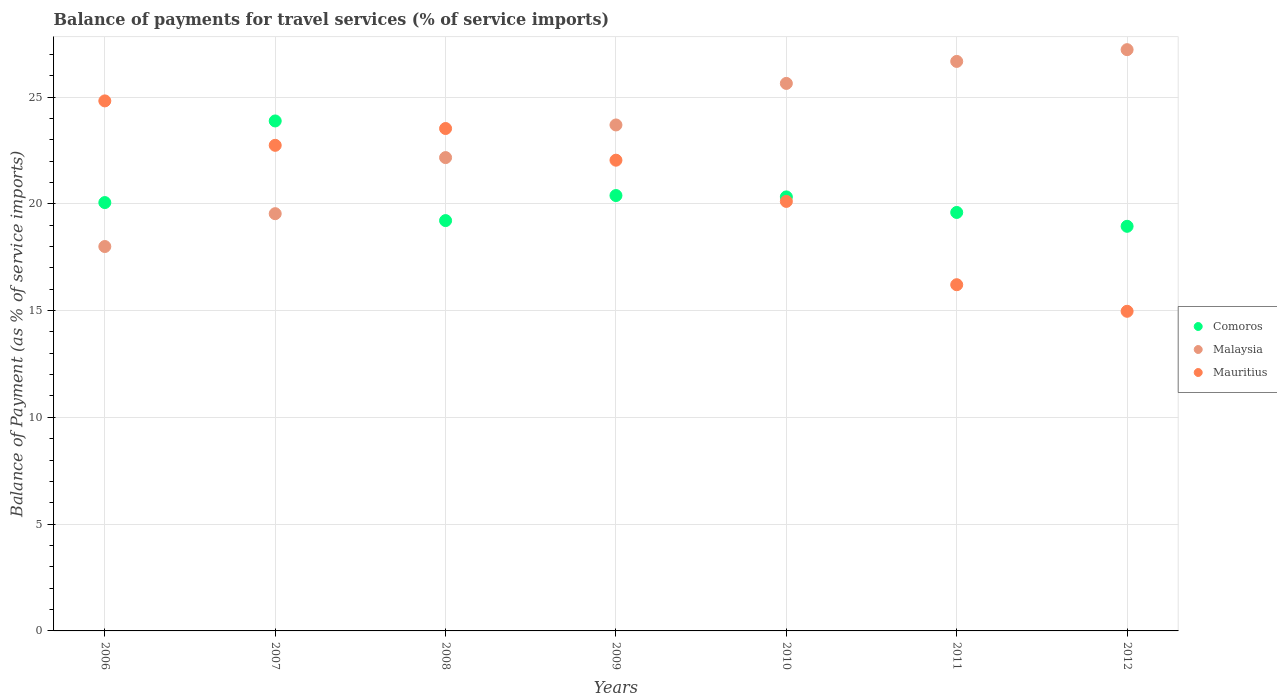Is the number of dotlines equal to the number of legend labels?
Your answer should be compact. Yes. What is the balance of payments for travel services in Comoros in 2009?
Offer a very short reply. 20.39. Across all years, what is the maximum balance of payments for travel services in Comoros?
Ensure brevity in your answer.  23.88. Across all years, what is the minimum balance of payments for travel services in Malaysia?
Give a very brief answer. 18. In which year was the balance of payments for travel services in Comoros maximum?
Keep it short and to the point. 2007. In which year was the balance of payments for travel services in Comoros minimum?
Give a very brief answer. 2012. What is the total balance of payments for travel services in Comoros in the graph?
Provide a succinct answer. 142.4. What is the difference between the balance of payments for travel services in Mauritius in 2007 and that in 2009?
Your response must be concise. 0.7. What is the difference between the balance of payments for travel services in Mauritius in 2012 and the balance of payments for travel services in Comoros in 2008?
Offer a terse response. -4.25. What is the average balance of payments for travel services in Mauritius per year?
Make the answer very short. 20.63. In the year 2007, what is the difference between the balance of payments for travel services in Malaysia and balance of payments for travel services in Comoros?
Offer a very short reply. -4.34. What is the ratio of the balance of payments for travel services in Mauritius in 2006 to that in 2010?
Make the answer very short. 1.23. Is the balance of payments for travel services in Malaysia in 2010 less than that in 2011?
Your answer should be very brief. Yes. What is the difference between the highest and the second highest balance of payments for travel services in Comoros?
Keep it short and to the point. 3.49. What is the difference between the highest and the lowest balance of payments for travel services in Malaysia?
Give a very brief answer. 9.22. What is the difference between two consecutive major ticks on the Y-axis?
Ensure brevity in your answer.  5. Does the graph contain grids?
Give a very brief answer. Yes. How many legend labels are there?
Offer a very short reply. 3. What is the title of the graph?
Give a very brief answer. Balance of payments for travel services (% of service imports). Does "Aruba" appear as one of the legend labels in the graph?
Your answer should be very brief. No. What is the label or title of the Y-axis?
Offer a terse response. Balance of Payment (as % of service imports). What is the Balance of Payment (as % of service imports) in Comoros in 2006?
Your answer should be very brief. 20.06. What is the Balance of Payment (as % of service imports) in Malaysia in 2006?
Your answer should be very brief. 18. What is the Balance of Payment (as % of service imports) of Mauritius in 2006?
Offer a terse response. 24.82. What is the Balance of Payment (as % of service imports) in Comoros in 2007?
Keep it short and to the point. 23.88. What is the Balance of Payment (as % of service imports) in Malaysia in 2007?
Give a very brief answer. 19.54. What is the Balance of Payment (as % of service imports) in Mauritius in 2007?
Provide a short and direct response. 22.74. What is the Balance of Payment (as % of service imports) in Comoros in 2008?
Ensure brevity in your answer.  19.21. What is the Balance of Payment (as % of service imports) in Malaysia in 2008?
Give a very brief answer. 22.16. What is the Balance of Payment (as % of service imports) in Mauritius in 2008?
Your response must be concise. 23.52. What is the Balance of Payment (as % of service imports) of Comoros in 2009?
Keep it short and to the point. 20.39. What is the Balance of Payment (as % of service imports) in Malaysia in 2009?
Ensure brevity in your answer.  23.69. What is the Balance of Payment (as % of service imports) of Mauritius in 2009?
Your answer should be compact. 22.04. What is the Balance of Payment (as % of service imports) of Comoros in 2010?
Provide a short and direct response. 20.32. What is the Balance of Payment (as % of service imports) of Malaysia in 2010?
Offer a terse response. 25.64. What is the Balance of Payment (as % of service imports) in Mauritius in 2010?
Ensure brevity in your answer.  20.11. What is the Balance of Payment (as % of service imports) in Comoros in 2011?
Make the answer very short. 19.59. What is the Balance of Payment (as % of service imports) in Malaysia in 2011?
Offer a terse response. 26.67. What is the Balance of Payment (as % of service imports) in Mauritius in 2011?
Offer a terse response. 16.21. What is the Balance of Payment (as % of service imports) of Comoros in 2012?
Provide a short and direct response. 18.95. What is the Balance of Payment (as % of service imports) of Malaysia in 2012?
Your answer should be compact. 27.22. What is the Balance of Payment (as % of service imports) of Mauritius in 2012?
Offer a very short reply. 14.97. Across all years, what is the maximum Balance of Payment (as % of service imports) in Comoros?
Make the answer very short. 23.88. Across all years, what is the maximum Balance of Payment (as % of service imports) in Malaysia?
Your response must be concise. 27.22. Across all years, what is the maximum Balance of Payment (as % of service imports) in Mauritius?
Provide a succinct answer. 24.82. Across all years, what is the minimum Balance of Payment (as % of service imports) in Comoros?
Offer a terse response. 18.95. Across all years, what is the minimum Balance of Payment (as % of service imports) of Malaysia?
Your answer should be compact. 18. Across all years, what is the minimum Balance of Payment (as % of service imports) in Mauritius?
Offer a very short reply. 14.97. What is the total Balance of Payment (as % of service imports) in Comoros in the graph?
Offer a terse response. 142.4. What is the total Balance of Payment (as % of service imports) of Malaysia in the graph?
Your answer should be very brief. 162.91. What is the total Balance of Payment (as % of service imports) in Mauritius in the graph?
Make the answer very short. 144.41. What is the difference between the Balance of Payment (as % of service imports) in Comoros in 2006 and that in 2007?
Offer a very short reply. -3.82. What is the difference between the Balance of Payment (as % of service imports) of Malaysia in 2006 and that in 2007?
Offer a very short reply. -1.54. What is the difference between the Balance of Payment (as % of service imports) in Mauritius in 2006 and that in 2007?
Make the answer very short. 2.08. What is the difference between the Balance of Payment (as % of service imports) in Comoros in 2006 and that in 2008?
Give a very brief answer. 0.84. What is the difference between the Balance of Payment (as % of service imports) of Malaysia in 2006 and that in 2008?
Provide a succinct answer. -4.16. What is the difference between the Balance of Payment (as % of service imports) in Mauritius in 2006 and that in 2008?
Make the answer very short. 1.29. What is the difference between the Balance of Payment (as % of service imports) of Comoros in 2006 and that in 2009?
Your response must be concise. -0.33. What is the difference between the Balance of Payment (as % of service imports) in Malaysia in 2006 and that in 2009?
Make the answer very short. -5.69. What is the difference between the Balance of Payment (as % of service imports) in Mauritius in 2006 and that in 2009?
Offer a very short reply. 2.78. What is the difference between the Balance of Payment (as % of service imports) in Comoros in 2006 and that in 2010?
Provide a short and direct response. -0.27. What is the difference between the Balance of Payment (as % of service imports) of Malaysia in 2006 and that in 2010?
Your answer should be very brief. -7.64. What is the difference between the Balance of Payment (as % of service imports) of Mauritius in 2006 and that in 2010?
Give a very brief answer. 4.71. What is the difference between the Balance of Payment (as % of service imports) of Comoros in 2006 and that in 2011?
Offer a very short reply. 0.46. What is the difference between the Balance of Payment (as % of service imports) of Malaysia in 2006 and that in 2011?
Provide a succinct answer. -8.67. What is the difference between the Balance of Payment (as % of service imports) in Mauritius in 2006 and that in 2011?
Provide a short and direct response. 8.61. What is the difference between the Balance of Payment (as % of service imports) in Comoros in 2006 and that in 2012?
Ensure brevity in your answer.  1.11. What is the difference between the Balance of Payment (as % of service imports) in Malaysia in 2006 and that in 2012?
Your answer should be compact. -9.22. What is the difference between the Balance of Payment (as % of service imports) of Mauritius in 2006 and that in 2012?
Offer a terse response. 9.85. What is the difference between the Balance of Payment (as % of service imports) in Comoros in 2007 and that in 2008?
Offer a very short reply. 4.67. What is the difference between the Balance of Payment (as % of service imports) of Malaysia in 2007 and that in 2008?
Keep it short and to the point. -2.63. What is the difference between the Balance of Payment (as % of service imports) of Mauritius in 2007 and that in 2008?
Make the answer very short. -0.79. What is the difference between the Balance of Payment (as % of service imports) of Comoros in 2007 and that in 2009?
Provide a short and direct response. 3.49. What is the difference between the Balance of Payment (as % of service imports) in Malaysia in 2007 and that in 2009?
Your answer should be compact. -4.15. What is the difference between the Balance of Payment (as % of service imports) in Mauritius in 2007 and that in 2009?
Provide a short and direct response. 0.7. What is the difference between the Balance of Payment (as % of service imports) in Comoros in 2007 and that in 2010?
Ensure brevity in your answer.  3.56. What is the difference between the Balance of Payment (as % of service imports) of Malaysia in 2007 and that in 2010?
Your response must be concise. -6.1. What is the difference between the Balance of Payment (as % of service imports) in Mauritius in 2007 and that in 2010?
Offer a terse response. 2.63. What is the difference between the Balance of Payment (as % of service imports) in Comoros in 2007 and that in 2011?
Your answer should be very brief. 4.28. What is the difference between the Balance of Payment (as % of service imports) of Malaysia in 2007 and that in 2011?
Your answer should be compact. -7.13. What is the difference between the Balance of Payment (as % of service imports) of Mauritius in 2007 and that in 2011?
Offer a terse response. 6.53. What is the difference between the Balance of Payment (as % of service imports) of Comoros in 2007 and that in 2012?
Provide a short and direct response. 4.93. What is the difference between the Balance of Payment (as % of service imports) in Malaysia in 2007 and that in 2012?
Provide a short and direct response. -7.68. What is the difference between the Balance of Payment (as % of service imports) in Mauritius in 2007 and that in 2012?
Offer a terse response. 7.77. What is the difference between the Balance of Payment (as % of service imports) of Comoros in 2008 and that in 2009?
Offer a terse response. -1.17. What is the difference between the Balance of Payment (as % of service imports) of Malaysia in 2008 and that in 2009?
Ensure brevity in your answer.  -1.53. What is the difference between the Balance of Payment (as % of service imports) in Mauritius in 2008 and that in 2009?
Provide a succinct answer. 1.48. What is the difference between the Balance of Payment (as % of service imports) in Comoros in 2008 and that in 2010?
Give a very brief answer. -1.11. What is the difference between the Balance of Payment (as % of service imports) of Malaysia in 2008 and that in 2010?
Make the answer very short. -3.47. What is the difference between the Balance of Payment (as % of service imports) in Mauritius in 2008 and that in 2010?
Offer a very short reply. 3.41. What is the difference between the Balance of Payment (as % of service imports) in Comoros in 2008 and that in 2011?
Give a very brief answer. -0.38. What is the difference between the Balance of Payment (as % of service imports) of Malaysia in 2008 and that in 2011?
Offer a terse response. -4.5. What is the difference between the Balance of Payment (as % of service imports) in Mauritius in 2008 and that in 2011?
Make the answer very short. 7.31. What is the difference between the Balance of Payment (as % of service imports) in Comoros in 2008 and that in 2012?
Your response must be concise. 0.27. What is the difference between the Balance of Payment (as % of service imports) of Malaysia in 2008 and that in 2012?
Provide a succinct answer. -5.05. What is the difference between the Balance of Payment (as % of service imports) in Mauritius in 2008 and that in 2012?
Your response must be concise. 8.56. What is the difference between the Balance of Payment (as % of service imports) of Comoros in 2009 and that in 2010?
Keep it short and to the point. 0.06. What is the difference between the Balance of Payment (as % of service imports) of Malaysia in 2009 and that in 2010?
Your answer should be very brief. -1.95. What is the difference between the Balance of Payment (as % of service imports) in Mauritius in 2009 and that in 2010?
Provide a succinct answer. 1.93. What is the difference between the Balance of Payment (as % of service imports) in Comoros in 2009 and that in 2011?
Offer a very short reply. 0.79. What is the difference between the Balance of Payment (as % of service imports) in Malaysia in 2009 and that in 2011?
Give a very brief answer. -2.98. What is the difference between the Balance of Payment (as % of service imports) of Mauritius in 2009 and that in 2011?
Make the answer very short. 5.83. What is the difference between the Balance of Payment (as % of service imports) of Comoros in 2009 and that in 2012?
Ensure brevity in your answer.  1.44. What is the difference between the Balance of Payment (as % of service imports) of Malaysia in 2009 and that in 2012?
Your answer should be compact. -3.53. What is the difference between the Balance of Payment (as % of service imports) of Mauritius in 2009 and that in 2012?
Keep it short and to the point. 7.08. What is the difference between the Balance of Payment (as % of service imports) in Comoros in 2010 and that in 2011?
Your response must be concise. 0.73. What is the difference between the Balance of Payment (as % of service imports) in Malaysia in 2010 and that in 2011?
Your answer should be very brief. -1.03. What is the difference between the Balance of Payment (as % of service imports) of Mauritius in 2010 and that in 2011?
Ensure brevity in your answer.  3.9. What is the difference between the Balance of Payment (as % of service imports) of Comoros in 2010 and that in 2012?
Your response must be concise. 1.38. What is the difference between the Balance of Payment (as % of service imports) of Malaysia in 2010 and that in 2012?
Offer a terse response. -1.58. What is the difference between the Balance of Payment (as % of service imports) of Mauritius in 2010 and that in 2012?
Keep it short and to the point. 5.15. What is the difference between the Balance of Payment (as % of service imports) of Comoros in 2011 and that in 2012?
Provide a succinct answer. 0.65. What is the difference between the Balance of Payment (as % of service imports) in Malaysia in 2011 and that in 2012?
Your response must be concise. -0.55. What is the difference between the Balance of Payment (as % of service imports) of Mauritius in 2011 and that in 2012?
Your answer should be very brief. 1.24. What is the difference between the Balance of Payment (as % of service imports) in Comoros in 2006 and the Balance of Payment (as % of service imports) in Malaysia in 2007?
Your response must be concise. 0.52. What is the difference between the Balance of Payment (as % of service imports) of Comoros in 2006 and the Balance of Payment (as % of service imports) of Mauritius in 2007?
Make the answer very short. -2.68. What is the difference between the Balance of Payment (as % of service imports) of Malaysia in 2006 and the Balance of Payment (as % of service imports) of Mauritius in 2007?
Your answer should be compact. -4.74. What is the difference between the Balance of Payment (as % of service imports) in Comoros in 2006 and the Balance of Payment (as % of service imports) in Malaysia in 2008?
Provide a short and direct response. -2.11. What is the difference between the Balance of Payment (as % of service imports) of Comoros in 2006 and the Balance of Payment (as % of service imports) of Mauritius in 2008?
Ensure brevity in your answer.  -3.47. What is the difference between the Balance of Payment (as % of service imports) of Malaysia in 2006 and the Balance of Payment (as % of service imports) of Mauritius in 2008?
Offer a terse response. -5.53. What is the difference between the Balance of Payment (as % of service imports) in Comoros in 2006 and the Balance of Payment (as % of service imports) in Malaysia in 2009?
Provide a short and direct response. -3.63. What is the difference between the Balance of Payment (as % of service imports) of Comoros in 2006 and the Balance of Payment (as % of service imports) of Mauritius in 2009?
Your answer should be compact. -1.98. What is the difference between the Balance of Payment (as % of service imports) of Malaysia in 2006 and the Balance of Payment (as % of service imports) of Mauritius in 2009?
Give a very brief answer. -4.04. What is the difference between the Balance of Payment (as % of service imports) of Comoros in 2006 and the Balance of Payment (as % of service imports) of Malaysia in 2010?
Give a very brief answer. -5.58. What is the difference between the Balance of Payment (as % of service imports) of Comoros in 2006 and the Balance of Payment (as % of service imports) of Mauritius in 2010?
Your answer should be very brief. -0.05. What is the difference between the Balance of Payment (as % of service imports) in Malaysia in 2006 and the Balance of Payment (as % of service imports) in Mauritius in 2010?
Provide a succinct answer. -2.11. What is the difference between the Balance of Payment (as % of service imports) in Comoros in 2006 and the Balance of Payment (as % of service imports) in Malaysia in 2011?
Your answer should be compact. -6.61. What is the difference between the Balance of Payment (as % of service imports) of Comoros in 2006 and the Balance of Payment (as % of service imports) of Mauritius in 2011?
Offer a very short reply. 3.85. What is the difference between the Balance of Payment (as % of service imports) of Malaysia in 2006 and the Balance of Payment (as % of service imports) of Mauritius in 2011?
Make the answer very short. 1.79. What is the difference between the Balance of Payment (as % of service imports) in Comoros in 2006 and the Balance of Payment (as % of service imports) in Malaysia in 2012?
Your answer should be compact. -7.16. What is the difference between the Balance of Payment (as % of service imports) of Comoros in 2006 and the Balance of Payment (as % of service imports) of Mauritius in 2012?
Keep it short and to the point. 5.09. What is the difference between the Balance of Payment (as % of service imports) of Malaysia in 2006 and the Balance of Payment (as % of service imports) of Mauritius in 2012?
Ensure brevity in your answer.  3.03. What is the difference between the Balance of Payment (as % of service imports) in Comoros in 2007 and the Balance of Payment (as % of service imports) in Malaysia in 2008?
Make the answer very short. 1.72. What is the difference between the Balance of Payment (as % of service imports) of Comoros in 2007 and the Balance of Payment (as % of service imports) of Mauritius in 2008?
Offer a terse response. 0.35. What is the difference between the Balance of Payment (as % of service imports) of Malaysia in 2007 and the Balance of Payment (as % of service imports) of Mauritius in 2008?
Provide a short and direct response. -3.99. What is the difference between the Balance of Payment (as % of service imports) of Comoros in 2007 and the Balance of Payment (as % of service imports) of Malaysia in 2009?
Provide a short and direct response. 0.19. What is the difference between the Balance of Payment (as % of service imports) in Comoros in 2007 and the Balance of Payment (as % of service imports) in Mauritius in 2009?
Give a very brief answer. 1.84. What is the difference between the Balance of Payment (as % of service imports) of Malaysia in 2007 and the Balance of Payment (as % of service imports) of Mauritius in 2009?
Offer a very short reply. -2.5. What is the difference between the Balance of Payment (as % of service imports) in Comoros in 2007 and the Balance of Payment (as % of service imports) in Malaysia in 2010?
Provide a succinct answer. -1.76. What is the difference between the Balance of Payment (as % of service imports) of Comoros in 2007 and the Balance of Payment (as % of service imports) of Mauritius in 2010?
Your answer should be very brief. 3.77. What is the difference between the Balance of Payment (as % of service imports) of Malaysia in 2007 and the Balance of Payment (as % of service imports) of Mauritius in 2010?
Make the answer very short. -0.57. What is the difference between the Balance of Payment (as % of service imports) of Comoros in 2007 and the Balance of Payment (as % of service imports) of Malaysia in 2011?
Offer a terse response. -2.79. What is the difference between the Balance of Payment (as % of service imports) in Comoros in 2007 and the Balance of Payment (as % of service imports) in Mauritius in 2011?
Offer a terse response. 7.67. What is the difference between the Balance of Payment (as % of service imports) of Malaysia in 2007 and the Balance of Payment (as % of service imports) of Mauritius in 2011?
Your answer should be compact. 3.33. What is the difference between the Balance of Payment (as % of service imports) in Comoros in 2007 and the Balance of Payment (as % of service imports) in Malaysia in 2012?
Provide a short and direct response. -3.34. What is the difference between the Balance of Payment (as % of service imports) of Comoros in 2007 and the Balance of Payment (as % of service imports) of Mauritius in 2012?
Your response must be concise. 8.91. What is the difference between the Balance of Payment (as % of service imports) of Malaysia in 2007 and the Balance of Payment (as % of service imports) of Mauritius in 2012?
Give a very brief answer. 4.57. What is the difference between the Balance of Payment (as % of service imports) in Comoros in 2008 and the Balance of Payment (as % of service imports) in Malaysia in 2009?
Offer a terse response. -4.48. What is the difference between the Balance of Payment (as % of service imports) of Comoros in 2008 and the Balance of Payment (as % of service imports) of Mauritius in 2009?
Your answer should be compact. -2.83. What is the difference between the Balance of Payment (as % of service imports) of Malaysia in 2008 and the Balance of Payment (as % of service imports) of Mauritius in 2009?
Ensure brevity in your answer.  0.12. What is the difference between the Balance of Payment (as % of service imports) of Comoros in 2008 and the Balance of Payment (as % of service imports) of Malaysia in 2010?
Offer a very short reply. -6.42. What is the difference between the Balance of Payment (as % of service imports) in Comoros in 2008 and the Balance of Payment (as % of service imports) in Mauritius in 2010?
Ensure brevity in your answer.  -0.9. What is the difference between the Balance of Payment (as % of service imports) of Malaysia in 2008 and the Balance of Payment (as % of service imports) of Mauritius in 2010?
Ensure brevity in your answer.  2.05. What is the difference between the Balance of Payment (as % of service imports) of Comoros in 2008 and the Balance of Payment (as % of service imports) of Malaysia in 2011?
Your response must be concise. -7.45. What is the difference between the Balance of Payment (as % of service imports) of Comoros in 2008 and the Balance of Payment (as % of service imports) of Mauritius in 2011?
Provide a succinct answer. 3. What is the difference between the Balance of Payment (as % of service imports) in Malaysia in 2008 and the Balance of Payment (as % of service imports) in Mauritius in 2011?
Keep it short and to the point. 5.95. What is the difference between the Balance of Payment (as % of service imports) in Comoros in 2008 and the Balance of Payment (as % of service imports) in Malaysia in 2012?
Your answer should be compact. -8. What is the difference between the Balance of Payment (as % of service imports) of Comoros in 2008 and the Balance of Payment (as % of service imports) of Mauritius in 2012?
Provide a succinct answer. 4.25. What is the difference between the Balance of Payment (as % of service imports) in Malaysia in 2008 and the Balance of Payment (as % of service imports) in Mauritius in 2012?
Provide a succinct answer. 7.2. What is the difference between the Balance of Payment (as % of service imports) in Comoros in 2009 and the Balance of Payment (as % of service imports) in Malaysia in 2010?
Give a very brief answer. -5.25. What is the difference between the Balance of Payment (as % of service imports) of Comoros in 2009 and the Balance of Payment (as % of service imports) of Mauritius in 2010?
Your answer should be compact. 0.27. What is the difference between the Balance of Payment (as % of service imports) of Malaysia in 2009 and the Balance of Payment (as % of service imports) of Mauritius in 2010?
Make the answer very short. 3.58. What is the difference between the Balance of Payment (as % of service imports) of Comoros in 2009 and the Balance of Payment (as % of service imports) of Malaysia in 2011?
Your answer should be compact. -6.28. What is the difference between the Balance of Payment (as % of service imports) in Comoros in 2009 and the Balance of Payment (as % of service imports) in Mauritius in 2011?
Provide a short and direct response. 4.18. What is the difference between the Balance of Payment (as % of service imports) of Malaysia in 2009 and the Balance of Payment (as % of service imports) of Mauritius in 2011?
Your answer should be very brief. 7.48. What is the difference between the Balance of Payment (as % of service imports) in Comoros in 2009 and the Balance of Payment (as % of service imports) in Malaysia in 2012?
Your response must be concise. -6.83. What is the difference between the Balance of Payment (as % of service imports) in Comoros in 2009 and the Balance of Payment (as % of service imports) in Mauritius in 2012?
Your answer should be very brief. 5.42. What is the difference between the Balance of Payment (as % of service imports) in Malaysia in 2009 and the Balance of Payment (as % of service imports) in Mauritius in 2012?
Make the answer very short. 8.73. What is the difference between the Balance of Payment (as % of service imports) in Comoros in 2010 and the Balance of Payment (as % of service imports) in Malaysia in 2011?
Your answer should be very brief. -6.34. What is the difference between the Balance of Payment (as % of service imports) in Comoros in 2010 and the Balance of Payment (as % of service imports) in Mauritius in 2011?
Your answer should be very brief. 4.11. What is the difference between the Balance of Payment (as % of service imports) of Malaysia in 2010 and the Balance of Payment (as % of service imports) of Mauritius in 2011?
Provide a succinct answer. 9.43. What is the difference between the Balance of Payment (as % of service imports) of Comoros in 2010 and the Balance of Payment (as % of service imports) of Malaysia in 2012?
Offer a terse response. -6.89. What is the difference between the Balance of Payment (as % of service imports) in Comoros in 2010 and the Balance of Payment (as % of service imports) in Mauritius in 2012?
Give a very brief answer. 5.36. What is the difference between the Balance of Payment (as % of service imports) of Malaysia in 2010 and the Balance of Payment (as % of service imports) of Mauritius in 2012?
Make the answer very short. 10.67. What is the difference between the Balance of Payment (as % of service imports) in Comoros in 2011 and the Balance of Payment (as % of service imports) in Malaysia in 2012?
Ensure brevity in your answer.  -7.62. What is the difference between the Balance of Payment (as % of service imports) of Comoros in 2011 and the Balance of Payment (as % of service imports) of Mauritius in 2012?
Offer a very short reply. 4.63. What is the difference between the Balance of Payment (as % of service imports) of Malaysia in 2011 and the Balance of Payment (as % of service imports) of Mauritius in 2012?
Provide a succinct answer. 11.7. What is the average Balance of Payment (as % of service imports) of Comoros per year?
Keep it short and to the point. 20.34. What is the average Balance of Payment (as % of service imports) of Malaysia per year?
Keep it short and to the point. 23.27. What is the average Balance of Payment (as % of service imports) of Mauritius per year?
Make the answer very short. 20.63. In the year 2006, what is the difference between the Balance of Payment (as % of service imports) in Comoros and Balance of Payment (as % of service imports) in Malaysia?
Your answer should be compact. 2.06. In the year 2006, what is the difference between the Balance of Payment (as % of service imports) of Comoros and Balance of Payment (as % of service imports) of Mauritius?
Provide a succinct answer. -4.76. In the year 2006, what is the difference between the Balance of Payment (as % of service imports) in Malaysia and Balance of Payment (as % of service imports) in Mauritius?
Provide a short and direct response. -6.82. In the year 2007, what is the difference between the Balance of Payment (as % of service imports) in Comoros and Balance of Payment (as % of service imports) in Malaysia?
Make the answer very short. 4.34. In the year 2007, what is the difference between the Balance of Payment (as % of service imports) in Comoros and Balance of Payment (as % of service imports) in Mauritius?
Your response must be concise. 1.14. In the year 2007, what is the difference between the Balance of Payment (as % of service imports) of Malaysia and Balance of Payment (as % of service imports) of Mauritius?
Offer a very short reply. -3.2. In the year 2008, what is the difference between the Balance of Payment (as % of service imports) of Comoros and Balance of Payment (as % of service imports) of Malaysia?
Provide a short and direct response. -2.95. In the year 2008, what is the difference between the Balance of Payment (as % of service imports) in Comoros and Balance of Payment (as % of service imports) in Mauritius?
Give a very brief answer. -4.31. In the year 2008, what is the difference between the Balance of Payment (as % of service imports) of Malaysia and Balance of Payment (as % of service imports) of Mauritius?
Make the answer very short. -1.36. In the year 2009, what is the difference between the Balance of Payment (as % of service imports) in Comoros and Balance of Payment (as % of service imports) in Malaysia?
Provide a succinct answer. -3.31. In the year 2009, what is the difference between the Balance of Payment (as % of service imports) of Comoros and Balance of Payment (as % of service imports) of Mauritius?
Give a very brief answer. -1.65. In the year 2009, what is the difference between the Balance of Payment (as % of service imports) of Malaysia and Balance of Payment (as % of service imports) of Mauritius?
Your answer should be very brief. 1.65. In the year 2010, what is the difference between the Balance of Payment (as % of service imports) in Comoros and Balance of Payment (as % of service imports) in Malaysia?
Your answer should be compact. -5.31. In the year 2010, what is the difference between the Balance of Payment (as % of service imports) of Comoros and Balance of Payment (as % of service imports) of Mauritius?
Your response must be concise. 0.21. In the year 2010, what is the difference between the Balance of Payment (as % of service imports) in Malaysia and Balance of Payment (as % of service imports) in Mauritius?
Keep it short and to the point. 5.53. In the year 2011, what is the difference between the Balance of Payment (as % of service imports) in Comoros and Balance of Payment (as % of service imports) in Malaysia?
Provide a short and direct response. -7.07. In the year 2011, what is the difference between the Balance of Payment (as % of service imports) in Comoros and Balance of Payment (as % of service imports) in Mauritius?
Keep it short and to the point. 3.38. In the year 2011, what is the difference between the Balance of Payment (as % of service imports) of Malaysia and Balance of Payment (as % of service imports) of Mauritius?
Give a very brief answer. 10.46. In the year 2012, what is the difference between the Balance of Payment (as % of service imports) of Comoros and Balance of Payment (as % of service imports) of Malaysia?
Offer a terse response. -8.27. In the year 2012, what is the difference between the Balance of Payment (as % of service imports) in Comoros and Balance of Payment (as % of service imports) in Mauritius?
Offer a terse response. 3.98. In the year 2012, what is the difference between the Balance of Payment (as % of service imports) in Malaysia and Balance of Payment (as % of service imports) in Mauritius?
Your response must be concise. 12.25. What is the ratio of the Balance of Payment (as % of service imports) in Comoros in 2006 to that in 2007?
Keep it short and to the point. 0.84. What is the ratio of the Balance of Payment (as % of service imports) of Malaysia in 2006 to that in 2007?
Offer a very short reply. 0.92. What is the ratio of the Balance of Payment (as % of service imports) in Mauritius in 2006 to that in 2007?
Offer a terse response. 1.09. What is the ratio of the Balance of Payment (as % of service imports) of Comoros in 2006 to that in 2008?
Make the answer very short. 1.04. What is the ratio of the Balance of Payment (as % of service imports) of Malaysia in 2006 to that in 2008?
Provide a short and direct response. 0.81. What is the ratio of the Balance of Payment (as % of service imports) in Mauritius in 2006 to that in 2008?
Ensure brevity in your answer.  1.05. What is the ratio of the Balance of Payment (as % of service imports) of Comoros in 2006 to that in 2009?
Keep it short and to the point. 0.98. What is the ratio of the Balance of Payment (as % of service imports) of Malaysia in 2006 to that in 2009?
Give a very brief answer. 0.76. What is the ratio of the Balance of Payment (as % of service imports) in Mauritius in 2006 to that in 2009?
Offer a very short reply. 1.13. What is the ratio of the Balance of Payment (as % of service imports) of Comoros in 2006 to that in 2010?
Offer a terse response. 0.99. What is the ratio of the Balance of Payment (as % of service imports) in Malaysia in 2006 to that in 2010?
Your answer should be compact. 0.7. What is the ratio of the Balance of Payment (as % of service imports) in Mauritius in 2006 to that in 2010?
Keep it short and to the point. 1.23. What is the ratio of the Balance of Payment (as % of service imports) in Comoros in 2006 to that in 2011?
Your answer should be compact. 1.02. What is the ratio of the Balance of Payment (as % of service imports) of Malaysia in 2006 to that in 2011?
Give a very brief answer. 0.68. What is the ratio of the Balance of Payment (as % of service imports) of Mauritius in 2006 to that in 2011?
Provide a short and direct response. 1.53. What is the ratio of the Balance of Payment (as % of service imports) in Comoros in 2006 to that in 2012?
Give a very brief answer. 1.06. What is the ratio of the Balance of Payment (as % of service imports) of Malaysia in 2006 to that in 2012?
Provide a succinct answer. 0.66. What is the ratio of the Balance of Payment (as % of service imports) in Mauritius in 2006 to that in 2012?
Your response must be concise. 1.66. What is the ratio of the Balance of Payment (as % of service imports) of Comoros in 2007 to that in 2008?
Your answer should be very brief. 1.24. What is the ratio of the Balance of Payment (as % of service imports) in Malaysia in 2007 to that in 2008?
Keep it short and to the point. 0.88. What is the ratio of the Balance of Payment (as % of service imports) in Mauritius in 2007 to that in 2008?
Your answer should be very brief. 0.97. What is the ratio of the Balance of Payment (as % of service imports) of Comoros in 2007 to that in 2009?
Ensure brevity in your answer.  1.17. What is the ratio of the Balance of Payment (as % of service imports) in Malaysia in 2007 to that in 2009?
Keep it short and to the point. 0.82. What is the ratio of the Balance of Payment (as % of service imports) in Mauritius in 2007 to that in 2009?
Keep it short and to the point. 1.03. What is the ratio of the Balance of Payment (as % of service imports) of Comoros in 2007 to that in 2010?
Offer a very short reply. 1.18. What is the ratio of the Balance of Payment (as % of service imports) in Malaysia in 2007 to that in 2010?
Give a very brief answer. 0.76. What is the ratio of the Balance of Payment (as % of service imports) of Mauritius in 2007 to that in 2010?
Your response must be concise. 1.13. What is the ratio of the Balance of Payment (as % of service imports) of Comoros in 2007 to that in 2011?
Make the answer very short. 1.22. What is the ratio of the Balance of Payment (as % of service imports) in Malaysia in 2007 to that in 2011?
Your answer should be compact. 0.73. What is the ratio of the Balance of Payment (as % of service imports) of Mauritius in 2007 to that in 2011?
Ensure brevity in your answer.  1.4. What is the ratio of the Balance of Payment (as % of service imports) of Comoros in 2007 to that in 2012?
Provide a succinct answer. 1.26. What is the ratio of the Balance of Payment (as % of service imports) of Malaysia in 2007 to that in 2012?
Provide a succinct answer. 0.72. What is the ratio of the Balance of Payment (as % of service imports) of Mauritius in 2007 to that in 2012?
Provide a short and direct response. 1.52. What is the ratio of the Balance of Payment (as % of service imports) of Comoros in 2008 to that in 2009?
Offer a terse response. 0.94. What is the ratio of the Balance of Payment (as % of service imports) of Malaysia in 2008 to that in 2009?
Keep it short and to the point. 0.94. What is the ratio of the Balance of Payment (as % of service imports) of Mauritius in 2008 to that in 2009?
Provide a succinct answer. 1.07. What is the ratio of the Balance of Payment (as % of service imports) of Comoros in 2008 to that in 2010?
Your answer should be compact. 0.95. What is the ratio of the Balance of Payment (as % of service imports) of Malaysia in 2008 to that in 2010?
Offer a very short reply. 0.86. What is the ratio of the Balance of Payment (as % of service imports) of Mauritius in 2008 to that in 2010?
Offer a terse response. 1.17. What is the ratio of the Balance of Payment (as % of service imports) in Comoros in 2008 to that in 2011?
Provide a succinct answer. 0.98. What is the ratio of the Balance of Payment (as % of service imports) in Malaysia in 2008 to that in 2011?
Provide a short and direct response. 0.83. What is the ratio of the Balance of Payment (as % of service imports) of Mauritius in 2008 to that in 2011?
Offer a very short reply. 1.45. What is the ratio of the Balance of Payment (as % of service imports) in Comoros in 2008 to that in 2012?
Ensure brevity in your answer.  1.01. What is the ratio of the Balance of Payment (as % of service imports) in Malaysia in 2008 to that in 2012?
Keep it short and to the point. 0.81. What is the ratio of the Balance of Payment (as % of service imports) in Mauritius in 2008 to that in 2012?
Your response must be concise. 1.57. What is the ratio of the Balance of Payment (as % of service imports) in Comoros in 2009 to that in 2010?
Your answer should be very brief. 1. What is the ratio of the Balance of Payment (as % of service imports) of Malaysia in 2009 to that in 2010?
Give a very brief answer. 0.92. What is the ratio of the Balance of Payment (as % of service imports) in Mauritius in 2009 to that in 2010?
Your answer should be very brief. 1.1. What is the ratio of the Balance of Payment (as % of service imports) in Comoros in 2009 to that in 2011?
Your response must be concise. 1.04. What is the ratio of the Balance of Payment (as % of service imports) of Malaysia in 2009 to that in 2011?
Provide a succinct answer. 0.89. What is the ratio of the Balance of Payment (as % of service imports) of Mauritius in 2009 to that in 2011?
Your answer should be very brief. 1.36. What is the ratio of the Balance of Payment (as % of service imports) in Comoros in 2009 to that in 2012?
Offer a very short reply. 1.08. What is the ratio of the Balance of Payment (as % of service imports) in Malaysia in 2009 to that in 2012?
Offer a very short reply. 0.87. What is the ratio of the Balance of Payment (as % of service imports) of Mauritius in 2009 to that in 2012?
Give a very brief answer. 1.47. What is the ratio of the Balance of Payment (as % of service imports) of Comoros in 2010 to that in 2011?
Your answer should be compact. 1.04. What is the ratio of the Balance of Payment (as % of service imports) of Malaysia in 2010 to that in 2011?
Ensure brevity in your answer.  0.96. What is the ratio of the Balance of Payment (as % of service imports) of Mauritius in 2010 to that in 2011?
Offer a very short reply. 1.24. What is the ratio of the Balance of Payment (as % of service imports) in Comoros in 2010 to that in 2012?
Offer a very short reply. 1.07. What is the ratio of the Balance of Payment (as % of service imports) in Malaysia in 2010 to that in 2012?
Make the answer very short. 0.94. What is the ratio of the Balance of Payment (as % of service imports) of Mauritius in 2010 to that in 2012?
Make the answer very short. 1.34. What is the ratio of the Balance of Payment (as % of service imports) in Comoros in 2011 to that in 2012?
Provide a short and direct response. 1.03. What is the ratio of the Balance of Payment (as % of service imports) of Malaysia in 2011 to that in 2012?
Offer a very short reply. 0.98. What is the ratio of the Balance of Payment (as % of service imports) of Mauritius in 2011 to that in 2012?
Give a very brief answer. 1.08. What is the difference between the highest and the second highest Balance of Payment (as % of service imports) of Comoros?
Give a very brief answer. 3.49. What is the difference between the highest and the second highest Balance of Payment (as % of service imports) in Malaysia?
Provide a short and direct response. 0.55. What is the difference between the highest and the second highest Balance of Payment (as % of service imports) of Mauritius?
Your response must be concise. 1.29. What is the difference between the highest and the lowest Balance of Payment (as % of service imports) in Comoros?
Your answer should be very brief. 4.93. What is the difference between the highest and the lowest Balance of Payment (as % of service imports) in Malaysia?
Ensure brevity in your answer.  9.22. What is the difference between the highest and the lowest Balance of Payment (as % of service imports) in Mauritius?
Provide a short and direct response. 9.85. 